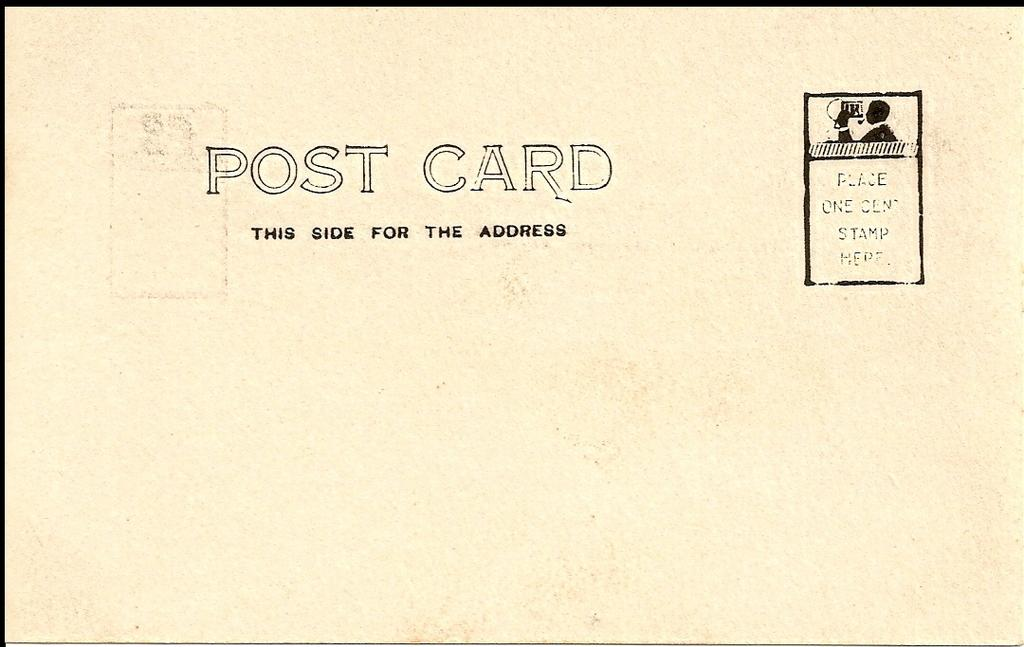<image>
Share a concise interpretation of the image provided. A that has POST CARD THIS SIDE FOR ADDRESS written on it. 